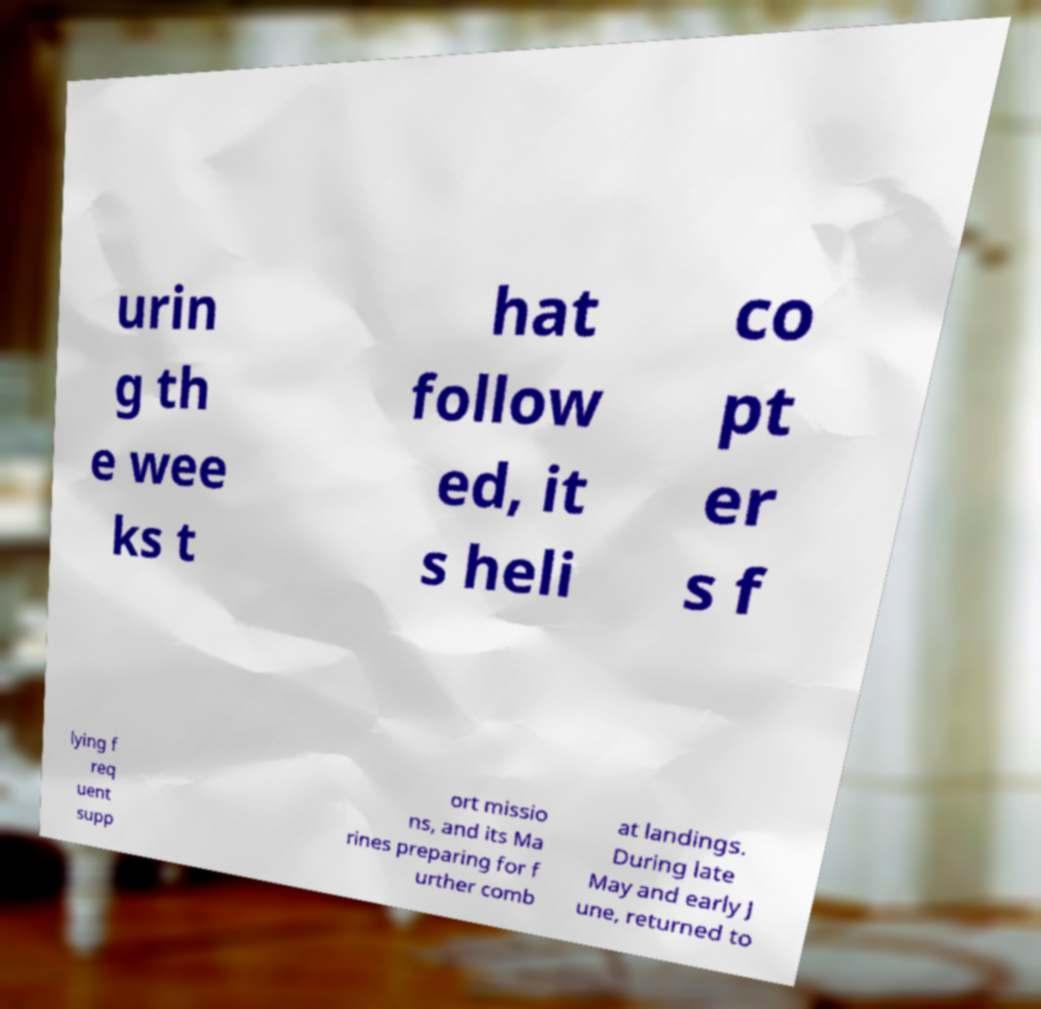Can you read and provide the text displayed in the image?This photo seems to have some interesting text. Can you extract and type it out for me? urin g th e wee ks t hat follow ed, it s heli co pt er s f lying f req uent supp ort missio ns, and its Ma rines preparing for f urther comb at landings. During late May and early J une, returned to 